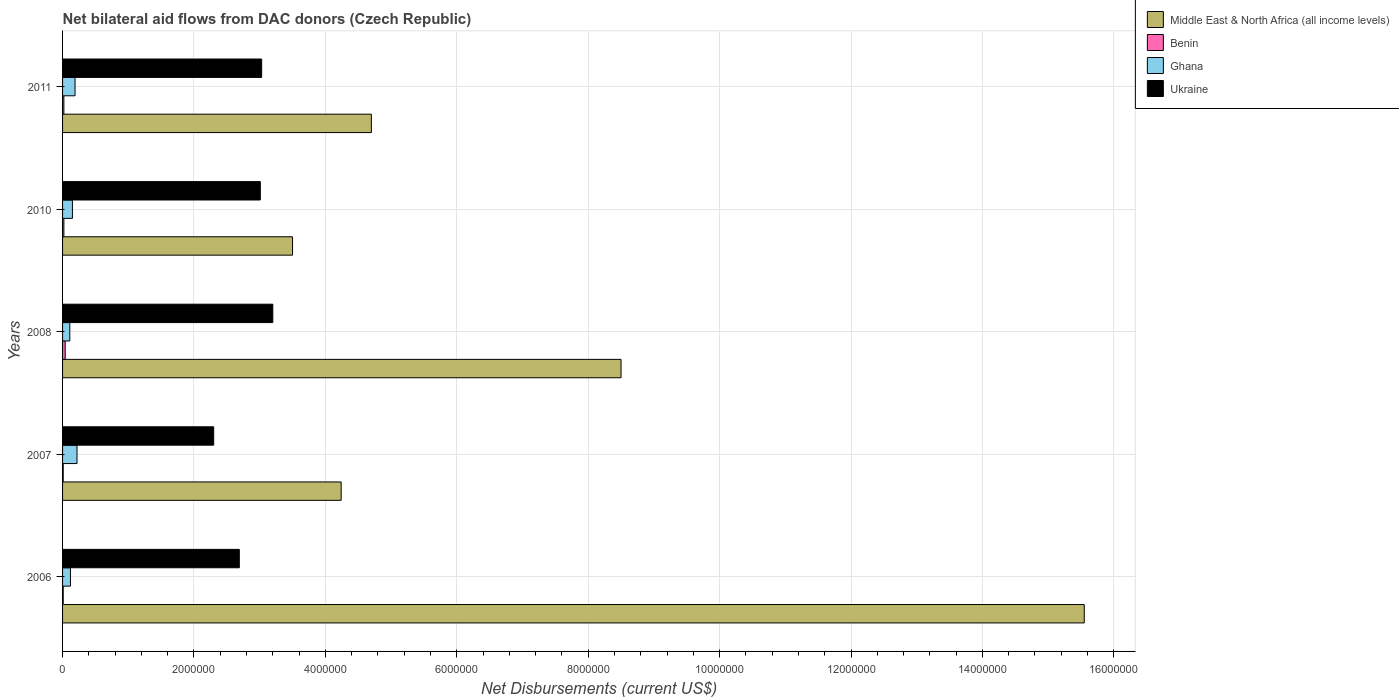Are the number of bars on each tick of the Y-axis equal?
Ensure brevity in your answer.  Yes. How many bars are there on the 3rd tick from the top?
Give a very brief answer. 4. How many bars are there on the 2nd tick from the bottom?
Your answer should be very brief. 4. What is the label of the 5th group of bars from the top?
Provide a short and direct response. 2006. What is the net bilateral aid flows in Ukraine in 2008?
Ensure brevity in your answer.  3.20e+06. Across all years, what is the maximum net bilateral aid flows in Ukraine?
Your answer should be compact. 3.20e+06. Across all years, what is the minimum net bilateral aid flows in Ukraine?
Keep it short and to the point. 2.30e+06. In which year was the net bilateral aid flows in Ghana maximum?
Ensure brevity in your answer.  2007. What is the difference between the net bilateral aid flows in Ghana in 2008 and that in 2010?
Give a very brief answer. -4.00e+04. What is the difference between the net bilateral aid flows in Benin in 2010 and the net bilateral aid flows in Middle East & North Africa (all income levels) in 2008?
Ensure brevity in your answer.  -8.48e+06. What is the average net bilateral aid flows in Ukraine per year?
Your response must be concise. 2.85e+06. In the year 2007, what is the difference between the net bilateral aid flows in Middle East & North Africa (all income levels) and net bilateral aid flows in Ukraine?
Offer a terse response. 1.94e+06. In how many years, is the net bilateral aid flows in Ukraine greater than 4400000 US$?
Your response must be concise. 0. What is the ratio of the net bilateral aid flows in Middle East & North Africa (all income levels) in 2008 to that in 2011?
Ensure brevity in your answer.  1.81. What is the difference between the highest and the lowest net bilateral aid flows in Ghana?
Offer a very short reply. 1.10e+05. In how many years, is the net bilateral aid flows in Middle East & North Africa (all income levels) greater than the average net bilateral aid flows in Middle East & North Africa (all income levels) taken over all years?
Your answer should be compact. 2. Is the sum of the net bilateral aid flows in Middle East & North Africa (all income levels) in 2006 and 2008 greater than the maximum net bilateral aid flows in Ukraine across all years?
Provide a short and direct response. Yes. Is it the case that in every year, the sum of the net bilateral aid flows in Ukraine and net bilateral aid flows in Middle East & North Africa (all income levels) is greater than the sum of net bilateral aid flows in Ghana and net bilateral aid flows in Benin?
Your answer should be compact. Yes. What does the 1st bar from the bottom in 2011 represents?
Your answer should be very brief. Middle East & North Africa (all income levels). What is the difference between two consecutive major ticks on the X-axis?
Ensure brevity in your answer.  2.00e+06. Where does the legend appear in the graph?
Your response must be concise. Top right. What is the title of the graph?
Your answer should be compact. Net bilateral aid flows from DAC donors (Czech Republic). What is the label or title of the X-axis?
Your answer should be compact. Net Disbursements (current US$). What is the label or title of the Y-axis?
Offer a terse response. Years. What is the Net Disbursements (current US$) in Middle East & North Africa (all income levels) in 2006?
Offer a very short reply. 1.56e+07. What is the Net Disbursements (current US$) in Ghana in 2006?
Your answer should be compact. 1.20e+05. What is the Net Disbursements (current US$) of Ukraine in 2006?
Your answer should be very brief. 2.69e+06. What is the Net Disbursements (current US$) in Middle East & North Africa (all income levels) in 2007?
Offer a very short reply. 4.24e+06. What is the Net Disbursements (current US$) of Benin in 2007?
Give a very brief answer. 10000. What is the Net Disbursements (current US$) of Ukraine in 2007?
Make the answer very short. 2.30e+06. What is the Net Disbursements (current US$) of Middle East & North Africa (all income levels) in 2008?
Make the answer very short. 8.50e+06. What is the Net Disbursements (current US$) of Ukraine in 2008?
Make the answer very short. 3.20e+06. What is the Net Disbursements (current US$) in Middle East & North Africa (all income levels) in 2010?
Make the answer very short. 3.50e+06. What is the Net Disbursements (current US$) of Benin in 2010?
Offer a very short reply. 2.00e+04. What is the Net Disbursements (current US$) of Ukraine in 2010?
Give a very brief answer. 3.01e+06. What is the Net Disbursements (current US$) in Middle East & North Africa (all income levels) in 2011?
Offer a very short reply. 4.70e+06. What is the Net Disbursements (current US$) of Ghana in 2011?
Offer a terse response. 1.90e+05. What is the Net Disbursements (current US$) in Ukraine in 2011?
Your answer should be compact. 3.03e+06. Across all years, what is the maximum Net Disbursements (current US$) of Middle East & North Africa (all income levels)?
Provide a short and direct response. 1.56e+07. Across all years, what is the maximum Net Disbursements (current US$) of Ghana?
Offer a very short reply. 2.20e+05. Across all years, what is the maximum Net Disbursements (current US$) in Ukraine?
Provide a succinct answer. 3.20e+06. Across all years, what is the minimum Net Disbursements (current US$) in Middle East & North Africa (all income levels)?
Ensure brevity in your answer.  3.50e+06. Across all years, what is the minimum Net Disbursements (current US$) in Benin?
Your answer should be compact. 10000. Across all years, what is the minimum Net Disbursements (current US$) in Ukraine?
Offer a terse response. 2.30e+06. What is the total Net Disbursements (current US$) in Middle East & North Africa (all income levels) in the graph?
Make the answer very short. 3.65e+07. What is the total Net Disbursements (current US$) of Benin in the graph?
Provide a succinct answer. 1.00e+05. What is the total Net Disbursements (current US$) in Ghana in the graph?
Offer a very short reply. 7.90e+05. What is the total Net Disbursements (current US$) in Ukraine in the graph?
Provide a short and direct response. 1.42e+07. What is the difference between the Net Disbursements (current US$) of Middle East & North Africa (all income levels) in 2006 and that in 2007?
Provide a short and direct response. 1.13e+07. What is the difference between the Net Disbursements (current US$) in Benin in 2006 and that in 2007?
Keep it short and to the point. 0. What is the difference between the Net Disbursements (current US$) in Middle East & North Africa (all income levels) in 2006 and that in 2008?
Offer a terse response. 7.05e+06. What is the difference between the Net Disbursements (current US$) in Benin in 2006 and that in 2008?
Your answer should be compact. -3.00e+04. What is the difference between the Net Disbursements (current US$) of Ukraine in 2006 and that in 2008?
Your response must be concise. -5.10e+05. What is the difference between the Net Disbursements (current US$) of Middle East & North Africa (all income levels) in 2006 and that in 2010?
Your response must be concise. 1.20e+07. What is the difference between the Net Disbursements (current US$) in Benin in 2006 and that in 2010?
Provide a short and direct response. -10000. What is the difference between the Net Disbursements (current US$) of Ghana in 2006 and that in 2010?
Give a very brief answer. -3.00e+04. What is the difference between the Net Disbursements (current US$) in Ukraine in 2006 and that in 2010?
Make the answer very short. -3.20e+05. What is the difference between the Net Disbursements (current US$) in Middle East & North Africa (all income levels) in 2006 and that in 2011?
Provide a succinct answer. 1.08e+07. What is the difference between the Net Disbursements (current US$) of Ghana in 2006 and that in 2011?
Offer a terse response. -7.00e+04. What is the difference between the Net Disbursements (current US$) of Middle East & North Africa (all income levels) in 2007 and that in 2008?
Your response must be concise. -4.26e+06. What is the difference between the Net Disbursements (current US$) in Ukraine in 2007 and that in 2008?
Offer a very short reply. -9.00e+05. What is the difference between the Net Disbursements (current US$) of Middle East & North Africa (all income levels) in 2007 and that in 2010?
Your answer should be very brief. 7.40e+05. What is the difference between the Net Disbursements (current US$) in Ukraine in 2007 and that in 2010?
Make the answer very short. -7.10e+05. What is the difference between the Net Disbursements (current US$) of Middle East & North Africa (all income levels) in 2007 and that in 2011?
Keep it short and to the point. -4.60e+05. What is the difference between the Net Disbursements (current US$) in Benin in 2007 and that in 2011?
Keep it short and to the point. -10000. What is the difference between the Net Disbursements (current US$) of Ukraine in 2007 and that in 2011?
Offer a terse response. -7.30e+05. What is the difference between the Net Disbursements (current US$) in Ghana in 2008 and that in 2010?
Make the answer very short. -4.00e+04. What is the difference between the Net Disbursements (current US$) in Middle East & North Africa (all income levels) in 2008 and that in 2011?
Your answer should be compact. 3.80e+06. What is the difference between the Net Disbursements (current US$) in Benin in 2008 and that in 2011?
Offer a terse response. 2.00e+04. What is the difference between the Net Disbursements (current US$) of Ukraine in 2008 and that in 2011?
Keep it short and to the point. 1.70e+05. What is the difference between the Net Disbursements (current US$) of Middle East & North Africa (all income levels) in 2010 and that in 2011?
Make the answer very short. -1.20e+06. What is the difference between the Net Disbursements (current US$) of Ukraine in 2010 and that in 2011?
Make the answer very short. -2.00e+04. What is the difference between the Net Disbursements (current US$) of Middle East & North Africa (all income levels) in 2006 and the Net Disbursements (current US$) of Benin in 2007?
Give a very brief answer. 1.55e+07. What is the difference between the Net Disbursements (current US$) of Middle East & North Africa (all income levels) in 2006 and the Net Disbursements (current US$) of Ghana in 2007?
Your answer should be compact. 1.53e+07. What is the difference between the Net Disbursements (current US$) in Middle East & North Africa (all income levels) in 2006 and the Net Disbursements (current US$) in Ukraine in 2007?
Your answer should be very brief. 1.32e+07. What is the difference between the Net Disbursements (current US$) of Benin in 2006 and the Net Disbursements (current US$) of Ghana in 2007?
Keep it short and to the point. -2.10e+05. What is the difference between the Net Disbursements (current US$) of Benin in 2006 and the Net Disbursements (current US$) of Ukraine in 2007?
Ensure brevity in your answer.  -2.29e+06. What is the difference between the Net Disbursements (current US$) in Ghana in 2006 and the Net Disbursements (current US$) in Ukraine in 2007?
Make the answer very short. -2.18e+06. What is the difference between the Net Disbursements (current US$) of Middle East & North Africa (all income levels) in 2006 and the Net Disbursements (current US$) of Benin in 2008?
Make the answer very short. 1.55e+07. What is the difference between the Net Disbursements (current US$) of Middle East & North Africa (all income levels) in 2006 and the Net Disbursements (current US$) of Ghana in 2008?
Your answer should be compact. 1.54e+07. What is the difference between the Net Disbursements (current US$) of Middle East & North Africa (all income levels) in 2006 and the Net Disbursements (current US$) of Ukraine in 2008?
Offer a terse response. 1.24e+07. What is the difference between the Net Disbursements (current US$) in Benin in 2006 and the Net Disbursements (current US$) in Ukraine in 2008?
Ensure brevity in your answer.  -3.19e+06. What is the difference between the Net Disbursements (current US$) in Ghana in 2006 and the Net Disbursements (current US$) in Ukraine in 2008?
Your response must be concise. -3.08e+06. What is the difference between the Net Disbursements (current US$) in Middle East & North Africa (all income levels) in 2006 and the Net Disbursements (current US$) in Benin in 2010?
Your answer should be compact. 1.55e+07. What is the difference between the Net Disbursements (current US$) of Middle East & North Africa (all income levels) in 2006 and the Net Disbursements (current US$) of Ghana in 2010?
Make the answer very short. 1.54e+07. What is the difference between the Net Disbursements (current US$) in Middle East & North Africa (all income levels) in 2006 and the Net Disbursements (current US$) in Ukraine in 2010?
Your response must be concise. 1.25e+07. What is the difference between the Net Disbursements (current US$) in Benin in 2006 and the Net Disbursements (current US$) in Ghana in 2010?
Ensure brevity in your answer.  -1.40e+05. What is the difference between the Net Disbursements (current US$) in Benin in 2006 and the Net Disbursements (current US$) in Ukraine in 2010?
Give a very brief answer. -3.00e+06. What is the difference between the Net Disbursements (current US$) of Ghana in 2006 and the Net Disbursements (current US$) of Ukraine in 2010?
Give a very brief answer. -2.89e+06. What is the difference between the Net Disbursements (current US$) of Middle East & North Africa (all income levels) in 2006 and the Net Disbursements (current US$) of Benin in 2011?
Your response must be concise. 1.55e+07. What is the difference between the Net Disbursements (current US$) in Middle East & North Africa (all income levels) in 2006 and the Net Disbursements (current US$) in Ghana in 2011?
Provide a succinct answer. 1.54e+07. What is the difference between the Net Disbursements (current US$) in Middle East & North Africa (all income levels) in 2006 and the Net Disbursements (current US$) in Ukraine in 2011?
Ensure brevity in your answer.  1.25e+07. What is the difference between the Net Disbursements (current US$) of Benin in 2006 and the Net Disbursements (current US$) of Ghana in 2011?
Provide a short and direct response. -1.80e+05. What is the difference between the Net Disbursements (current US$) of Benin in 2006 and the Net Disbursements (current US$) of Ukraine in 2011?
Your answer should be very brief. -3.02e+06. What is the difference between the Net Disbursements (current US$) of Ghana in 2006 and the Net Disbursements (current US$) of Ukraine in 2011?
Your answer should be very brief. -2.91e+06. What is the difference between the Net Disbursements (current US$) of Middle East & North Africa (all income levels) in 2007 and the Net Disbursements (current US$) of Benin in 2008?
Offer a terse response. 4.20e+06. What is the difference between the Net Disbursements (current US$) in Middle East & North Africa (all income levels) in 2007 and the Net Disbursements (current US$) in Ghana in 2008?
Offer a very short reply. 4.13e+06. What is the difference between the Net Disbursements (current US$) of Middle East & North Africa (all income levels) in 2007 and the Net Disbursements (current US$) of Ukraine in 2008?
Keep it short and to the point. 1.04e+06. What is the difference between the Net Disbursements (current US$) in Benin in 2007 and the Net Disbursements (current US$) in Ukraine in 2008?
Provide a short and direct response. -3.19e+06. What is the difference between the Net Disbursements (current US$) of Ghana in 2007 and the Net Disbursements (current US$) of Ukraine in 2008?
Your answer should be very brief. -2.98e+06. What is the difference between the Net Disbursements (current US$) of Middle East & North Africa (all income levels) in 2007 and the Net Disbursements (current US$) of Benin in 2010?
Your answer should be compact. 4.22e+06. What is the difference between the Net Disbursements (current US$) of Middle East & North Africa (all income levels) in 2007 and the Net Disbursements (current US$) of Ghana in 2010?
Provide a succinct answer. 4.09e+06. What is the difference between the Net Disbursements (current US$) in Middle East & North Africa (all income levels) in 2007 and the Net Disbursements (current US$) in Ukraine in 2010?
Your response must be concise. 1.23e+06. What is the difference between the Net Disbursements (current US$) of Benin in 2007 and the Net Disbursements (current US$) of Ukraine in 2010?
Offer a terse response. -3.00e+06. What is the difference between the Net Disbursements (current US$) in Ghana in 2007 and the Net Disbursements (current US$) in Ukraine in 2010?
Make the answer very short. -2.79e+06. What is the difference between the Net Disbursements (current US$) in Middle East & North Africa (all income levels) in 2007 and the Net Disbursements (current US$) in Benin in 2011?
Your response must be concise. 4.22e+06. What is the difference between the Net Disbursements (current US$) of Middle East & North Africa (all income levels) in 2007 and the Net Disbursements (current US$) of Ghana in 2011?
Offer a very short reply. 4.05e+06. What is the difference between the Net Disbursements (current US$) of Middle East & North Africa (all income levels) in 2007 and the Net Disbursements (current US$) of Ukraine in 2011?
Ensure brevity in your answer.  1.21e+06. What is the difference between the Net Disbursements (current US$) in Benin in 2007 and the Net Disbursements (current US$) in Ukraine in 2011?
Provide a short and direct response. -3.02e+06. What is the difference between the Net Disbursements (current US$) in Ghana in 2007 and the Net Disbursements (current US$) in Ukraine in 2011?
Provide a short and direct response. -2.81e+06. What is the difference between the Net Disbursements (current US$) of Middle East & North Africa (all income levels) in 2008 and the Net Disbursements (current US$) of Benin in 2010?
Ensure brevity in your answer.  8.48e+06. What is the difference between the Net Disbursements (current US$) of Middle East & North Africa (all income levels) in 2008 and the Net Disbursements (current US$) of Ghana in 2010?
Offer a very short reply. 8.35e+06. What is the difference between the Net Disbursements (current US$) in Middle East & North Africa (all income levels) in 2008 and the Net Disbursements (current US$) in Ukraine in 2010?
Provide a short and direct response. 5.49e+06. What is the difference between the Net Disbursements (current US$) of Benin in 2008 and the Net Disbursements (current US$) of Ukraine in 2010?
Your answer should be compact. -2.97e+06. What is the difference between the Net Disbursements (current US$) of Ghana in 2008 and the Net Disbursements (current US$) of Ukraine in 2010?
Your answer should be very brief. -2.90e+06. What is the difference between the Net Disbursements (current US$) of Middle East & North Africa (all income levels) in 2008 and the Net Disbursements (current US$) of Benin in 2011?
Ensure brevity in your answer.  8.48e+06. What is the difference between the Net Disbursements (current US$) of Middle East & North Africa (all income levels) in 2008 and the Net Disbursements (current US$) of Ghana in 2011?
Make the answer very short. 8.31e+06. What is the difference between the Net Disbursements (current US$) in Middle East & North Africa (all income levels) in 2008 and the Net Disbursements (current US$) in Ukraine in 2011?
Ensure brevity in your answer.  5.47e+06. What is the difference between the Net Disbursements (current US$) in Benin in 2008 and the Net Disbursements (current US$) in Ukraine in 2011?
Offer a very short reply. -2.99e+06. What is the difference between the Net Disbursements (current US$) of Ghana in 2008 and the Net Disbursements (current US$) of Ukraine in 2011?
Your answer should be compact. -2.92e+06. What is the difference between the Net Disbursements (current US$) in Middle East & North Africa (all income levels) in 2010 and the Net Disbursements (current US$) in Benin in 2011?
Your response must be concise. 3.48e+06. What is the difference between the Net Disbursements (current US$) of Middle East & North Africa (all income levels) in 2010 and the Net Disbursements (current US$) of Ghana in 2011?
Keep it short and to the point. 3.31e+06. What is the difference between the Net Disbursements (current US$) of Benin in 2010 and the Net Disbursements (current US$) of Ukraine in 2011?
Your answer should be very brief. -3.01e+06. What is the difference between the Net Disbursements (current US$) of Ghana in 2010 and the Net Disbursements (current US$) of Ukraine in 2011?
Ensure brevity in your answer.  -2.88e+06. What is the average Net Disbursements (current US$) in Middle East & North Africa (all income levels) per year?
Make the answer very short. 7.30e+06. What is the average Net Disbursements (current US$) in Benin per year?
Your response must be concise. 2.00e+04. What is the average Net Disbursements (current US$) in Ghana per year?
Your response must be concise. 1.58e+05. What is the average Net Disbursements (current US$) in Ukraine per year?
Offer a terse response. 2.85e+06. In the year 2006, what is the difference between the Net Disbursements (current US$) in Middle East & North Africa (all income levels) and Net Disbursements (current US$) in Benin?
Keep it short and to the point. 1.55e+07. In the year 2006, what is the difference between the Net Disbursements (current US$) of Middle East & North Africa (all income levels) and Net Disbursements (current US$) of Ghana?
Provide a short and direct response. 1.54e+07. In the year 2006, what is the difference between the Net Disbursements (current US$) of Middle East & North Africa (all income levels) and Net Disbursements (current US$) of Ukraine?
Make the answer very short. 1.29e+07. In the year 2006, what is the difference between the Net Disbursements (current US$) of Benin and Net Disbursements (current US$) of Ghana?
Make the answer very short. -1.10e+05. In the year 2006, what is the difference between the Net Disbursements (current US$) of Benin and Net Disbursements (current US$) of Ukraine?
Provide a short and direct response. -2.68e+06. In the year 2006, what is the difference between the Net Disbursements (current US$) of Ghana and Net Disbursements (current US$) of Ukraine?
Provide a succinct answer. -2.57e+06. In the year 2007, what is the difference between the Net Disbursements (current US$) in Middle East & North Africa (all income levels) and Net Disbursements (current US$) in Benin?
Offer a very short reply. 4.23e+06. In the year 2007, what is the difference between the Net Disbursements (current US$) of Middle East & North Africa (all income levels) and Net Disbursements (current US$) of Ghana?
Give a very brief answer. 4.02e+06. In the year 2007, what is the difference between the Net Disbursements (current US$) in Middle East & North Africa (all income levels) and Net Disbursements (current US$) in Ukraine?
Keep it short and to the point. 1.94e+06. In the year 2007, what is the difference between the Net Disbursements (current US$) in Benin and Net Disbursements (current US$) in Ghana?
Give a very brief answer. -2.10e+05. In the year 2007, what is the difference between the Net Disbursements (current US$) of Benin and Net Disbursements (current US$) of Ukraine?
Your response must be concise. -2.29e+06. In the year 2007, what is the difference between the Net Disbursements (current US$) of Ghana and Net Disbursements (current US$) of Ukraine?
Your answer should be compact. -2.08e+06. In the year 2008, what is the difference between the Net Disbursements (current US$) of Middle East & North Africa (all income levels) and Net Disbursements (current US$) of Benin?
Your answer should be compact. 8.46e+06. In the year 2008, what is the difference between the Net Disbursements (current US$) of Middle East & North Africa (all income levels) and Net Disbursements (current US$) of Ghana?
Provide a succinct answer. 8.39e+06. In the year 2008, what is the difference between the Net Disbursements (current US$) in Middle East & North Africa (all income levels) and Net Disbursements (current US$) in Ukraine?
Provide a short and direct response. 5.30e+06. In the year 2008, what is the difference between the Net Disbursements (current US$) in Benin and Net Disbursements (current US$) in Ukraine?
Your answer should be compact. -3.16e+06. In the year 2008, what is the difference between the Net Disbursements (current US$) of Ghana and Net Disbursements (current US$) of Ukraine?
Offer a terse response. -3.09e+06. In the year 2010, what is the difference between the Net Disbursements (current US$) of Middle East & North Africa (all income levels) and Net Disbursements (current US$) of Benin?
Make the answer very short. 3.48e+06. In the year 2010, what is the difference between the Net Disbursements (current US$) of Middle East & North Africa (all income levels) and Net Disbursements (current US$) of Ghana?
Keep it short and to the point. 3.35e+06. In the year 2010, what is the difference between the Net Disbursements (current US$) in Benin and Net Disbursements (current US$) in Ukraine?
Offer a very short reply. -2.99e+06. In the year 2010, what is the difference between the Net Disbursements (current US$) of Ghana and Net Disbursements (current US$) of Ukraine?
Offer a terse response. -2.86e+06. In the year 2011, what is the difference between the Net Disbursements (current US$) of Middle East & North Africa (all income levels) and Net Disbursements (current US$) of Benin?
Offer a very short reply. 4.68e+06. In the year 2011, what is the difference between the Net Disbursements (current US$) in Middle East & North Africa (all income levels) and Net Disbursements (current US$) in Ghana?
Your response must be concise. 4.51e+06. In the year 2011, what is the difference between the Net Disbursements (current US$) of Middle East & North Africa (all income levels) and Net Disbursements (current US$) of Ukraine?
Provide a succinct answer. 1.67e+06. In the year 2011, what is the difference between the Net Disbursements (current US$) in Benin and Net Disbursements (current US$) in Ghana?
Offer a terse response. -1.70e+05. In the year 2011, what is the difference between the Net Disbursements (current US$) of Benin and Net Disbursements (current US$) of Ukraine?
Keep it short and to the point. -3.01e+06. In the year 2011, what is the difference between the Net Disbursements (current US$) in Ghana and Net Disbursements (current US$) in Ukraine?
Provide a succinct answer. -2.84e+06. What is the ratio of the Net Disbursements (current US$) in Middle East & North Africa (all income levels) in 2006 to that in 2007?
Keep it short and to the point. 3.67. What is the ratio of the Net Disbursements (current US$) in Benin in 2006 to that in 2007?
Your answer should be compact. 1. What is the ratio of the Net Disbursements (current US$) in Ghana in 2006 to that in 2007?
Your response must be concise. 0.55. What is the ratio of the Net Disbursements (current US$) in Ukraine in 2006 to that in 2007?
Provide a succinct answer. 1.17. What is the ratio of the Net Disbursements (current US$) of Middle East & North Africa (all income levels) in 2006 to that in 2008?
Keep it short and to the point. 1.83. What is the ratio of the Net Disbursements (current US$) of Ghana in 2006 to that in 2008?
Your response must be concise. 1.09. What is the ratio of the Net Disbursements (current US$) in Ukraine in 2006 to that in 2008?
Offer a very short reply. 0.84. What is the ratio of the Net Disbursements (current US$) of Middle East & North Africa (all income levels) in 2006 to that in 2010?
Give a very brief answer. 4.44. What is the ratio of the Net Disbursements (current US$) of Benin in 2006 to that in 2010?
Offer a terse response. 0.5. What is the ratio of the Net Disbursements (current US$) of Ukraine in 2006 to that in 2010?
Offer a very short reply. 0.89. What is the ratio of the Net Disbursements (current US$) in Middle East & North Africa (all income levels) in 2006 to that in 2011?
Your answer should be very brief. 3.31. What is the ratio of the Net Disbursements (current US$) in Ghana in 2006 to that in 2011?
Offer a very short reply. 0.63. What is the ratio of the Net Disbursements (current US$) in Ukraine in 2006 to that in 2011?
Your response must be concise. 0.89. What is the ratio of the Net Disbursements (current US$) in Middle East & North Africa (all income levels) in 2007 to that in 2008?
Keep it short and to the point. 0.5. What is the ratio of the Net Disbursements (current US$) in Ghana in 2007 to that in 2008?
Ensure brevity in your answer.  2. What is the ratio of the Net Disbursements (current US$) of Ukraine in 2007 to that in 2008?
Offer a very short reply. 0.72. What is the ratio of the Net Disbursements (current US$) of Middle East & North Africa (all income levels) in 2007 to that in 2010?
Your answer should be compact. 1.21. What is the ratio of the Net Disbursements (current US$) in Ghana in 2007 to that in 2010?
Your answer should be very brief. 1.47. What is the ratio of the Net Disbursements (current US$) of Ukraine in 2007 to that in 2010?
Give a very brief answer. 0.76. What is the ratio of the Net Disbursements (current US$) in Middle East & North Africa (all income levels) in 2007 to that in 2011?
Your answer should be very brief. 0.9. What is the ratio of the Net Disbursements (current US$) in Ghana in 2007 to that in 2011?
Ensure brevity in your answer.  1.16. What is the ratio of the Net Disbursements (current US$) in Ukraine in 2007 to that in 2011?
Provide a succinct answer. 0.76. What is the ratio of the Net Disbursements (current US$) in Middle East & North Africa (all income levels) in 2008 to that in 2010?
Give a very brief answer. 2.43. What is the ratio of the Net Disbursements (current US$) in Benin in 2008 to that in 2010?
Your answer should be compact. 2. What is the ratio of the Net Disbursements (current US$) of Ghana in 2008 to that in 2010?
Ensure brevity in your answer.  0.73. What is the ratio of the Net Disbursements (current US$) of Ukraine in 2008 to that in 2010?
Offer a very short reply. 1.06. What is the ratio of the Net Disbursements (current US$) of Middle East & North Africa (all income levels) in 2008 to that in 2011?
Give a very brief answer. 1.81. What is the ratio of the Net Disbursements (current US$) in Ghana in 2008 to that in 2011?
Offer a very short reply. 0.58. What is the ratio of the Net Disbursements (current US$) of Ukraine in 2008 to that in 2011?
Keep it short and to the point. 1.06. What is the ratio of the Net Disbursements (current US$) of Middle East & North Africa (all income levels) in 2010 to that in 2011?
Your response must be concise. 0.74. What is the ratio of the Net Disbursements (current US$) in Benin in 2010 to that in 2011?
Give a very brief answer. 1. What is the ratio of the Net Disbursements (current US$) of Ghana in 2010 to that in 2011?
Keep it short and to the point. 0.79. What is the difference between the highest and the second highest Net Disbursements (current US$) in Middle East & North Africa (all income levels)?
Give a very brief answer. 7.05e+06. What is the difference between the highest and the second highest Net Disbursements (current US$) in Benin?
Offer a very short reply. 2.00e+04. What is the difference between the highest and the second highest Net Disbursements (current US$) of Ghana?
Your response must be concise. 3.00e+04. What is the difference between the highest and the lowest Net Disbursements (current US$) of Middle East & North Africa (all income levels)?
Give a very brief answer. 1.20e+07. What is the difference between the highest and the lowest Net Disbursements (current US$) of Benin?
Your response must be concise. 3.00e+04. What is the difference between the highest and the lowest Net Disbursements (current US$) of Ghana?
Your answer should be compact. 1.10e+05. What is the difference between the highest and the lowest Net Disbursements (current US$) of Ukraine?
Make the answer very short. 9.00e+05. 